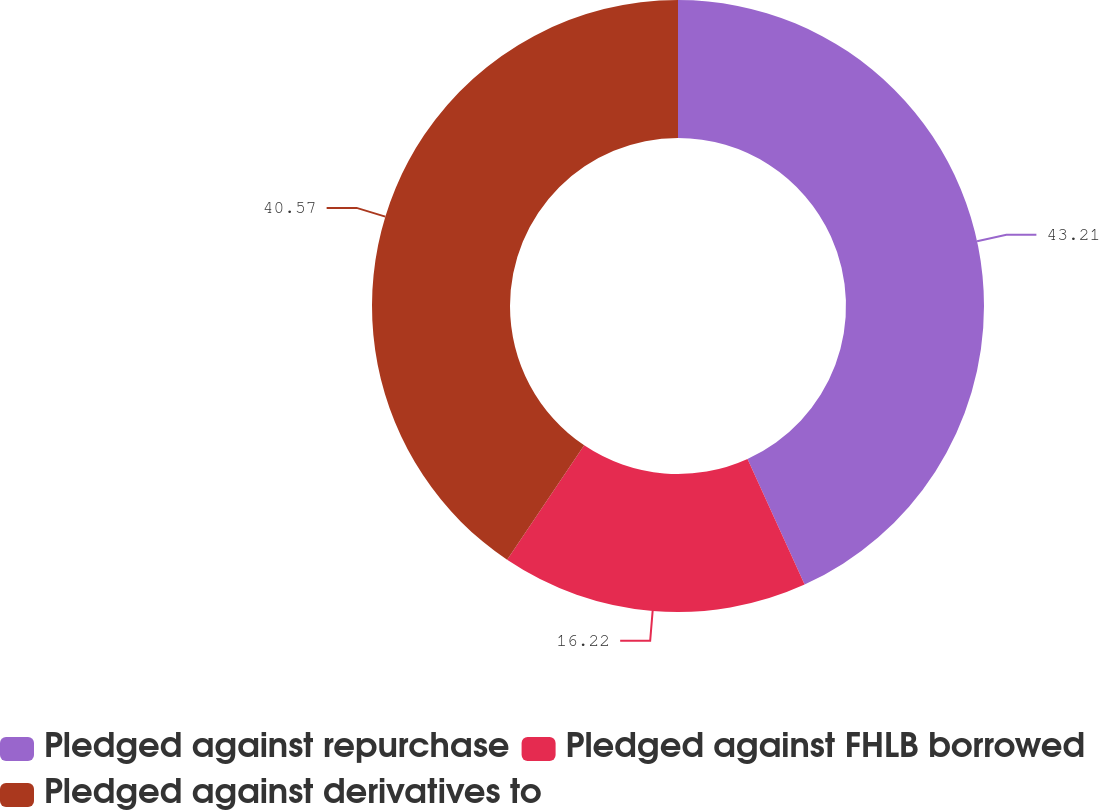<chart> <loc_0><loc_0><loc_500><loc_500><pie_chart><fcel>Pledged against repurchase<fcel>Pledged against FHLB borrowed<fcel>Pledged against derivatives to<nl><fcel>43.21%<fcel>16.22%<fcel>40.57%<nl></chart> 